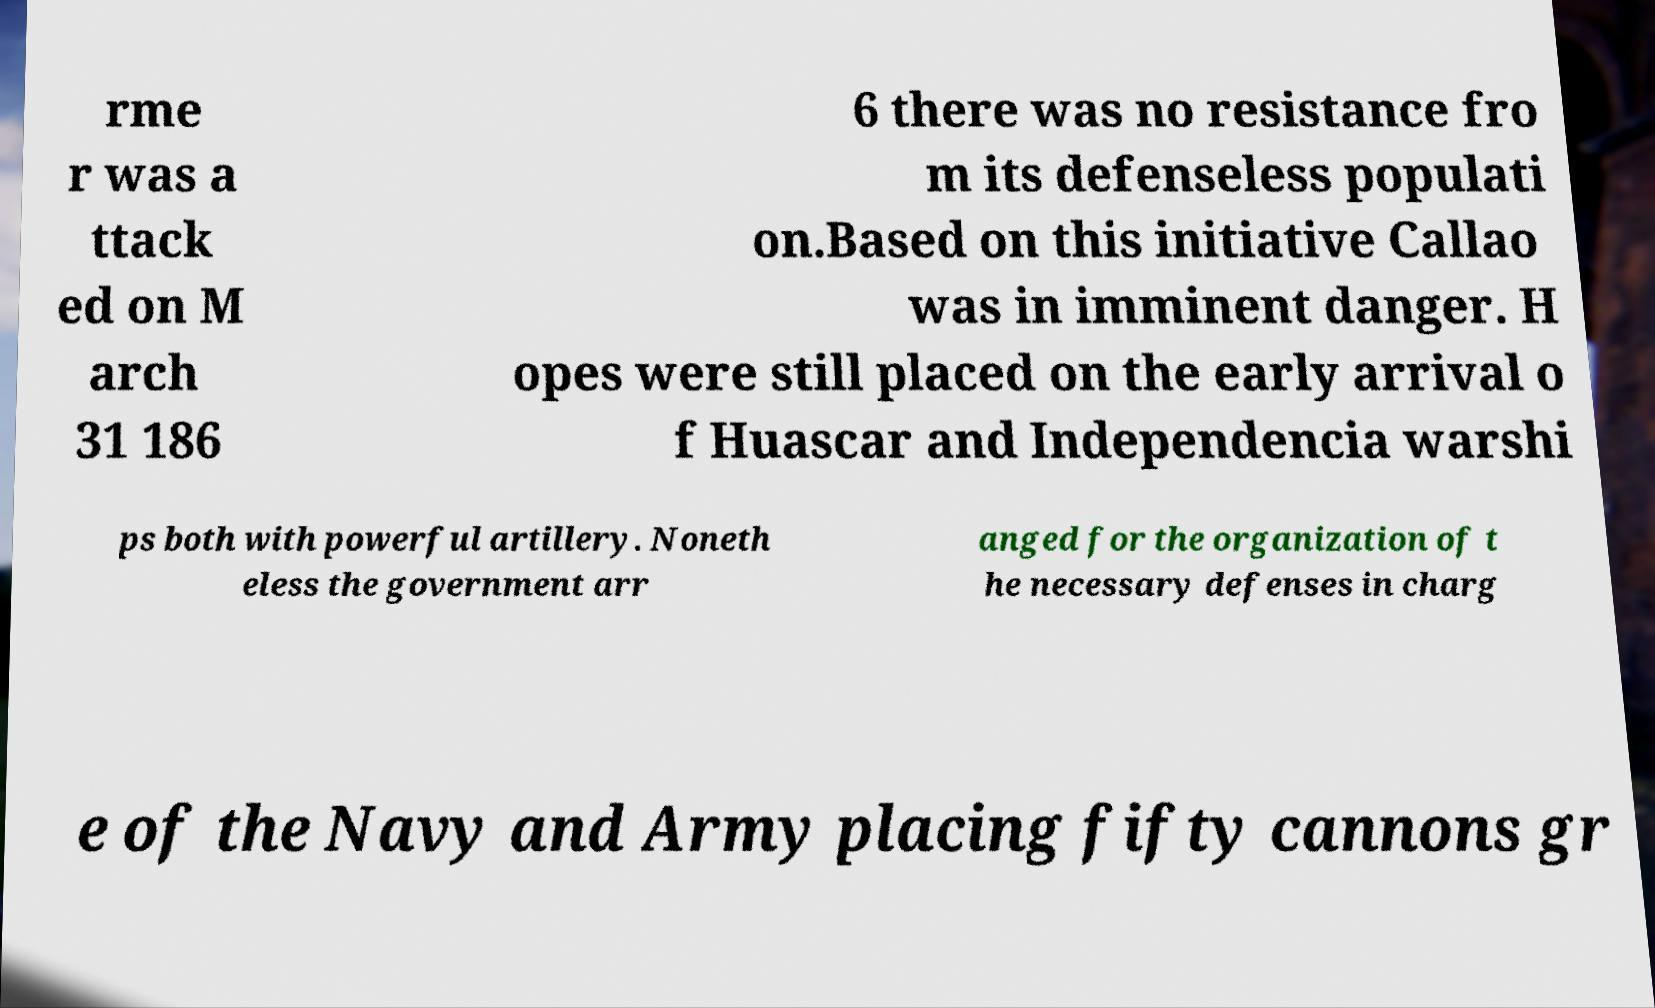Please read and relay the text visible in this image. What does it say? rme r was a ttack ed on M arch 31 186 6 there was no resistance fro m its defenseless populati on.Based on this initiative Callao was in imminent danger. H opes were still placed on the early arrival o f Huascar and Independencia warshi ps both with powerful artillery. Noneth eless the government arr anged for the organization of t he necessary defenses in charg e of the Navy and Army placing fifty cannons gr 